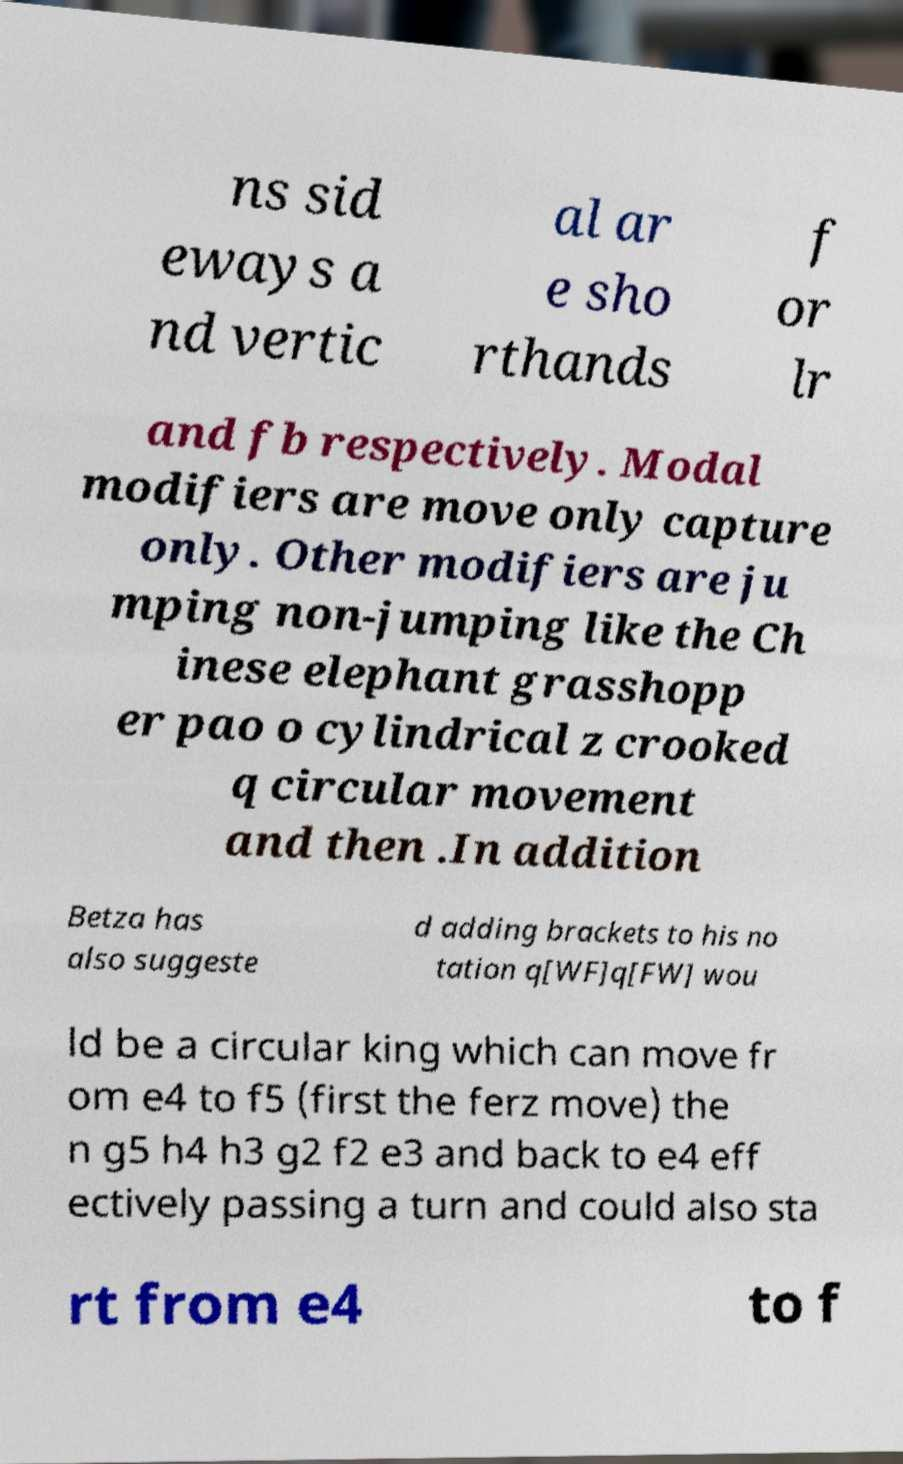For documentation purposes, I need the text within this image transcribed. Could you provide that? ns sid eways a nd vertic al ar e sho rthands f or lr and fb respectively. Modal modifiers are move only capture only. Other modifiers are ju mping non-jumping like the Ch inese elephant grasshopp er pao o cylindrical z crooked q circular movement and then .In addition Betza has also suggeste d adding brackets to his no tation q[WF]q[FW] wou ld be a circular king which can move fr om e4 to f5 (first the ferz move) the n g5 h4 h3 g2 f2 e3 and back to e4 eff ectively passing a turn and could also sta rt from e4 to f 